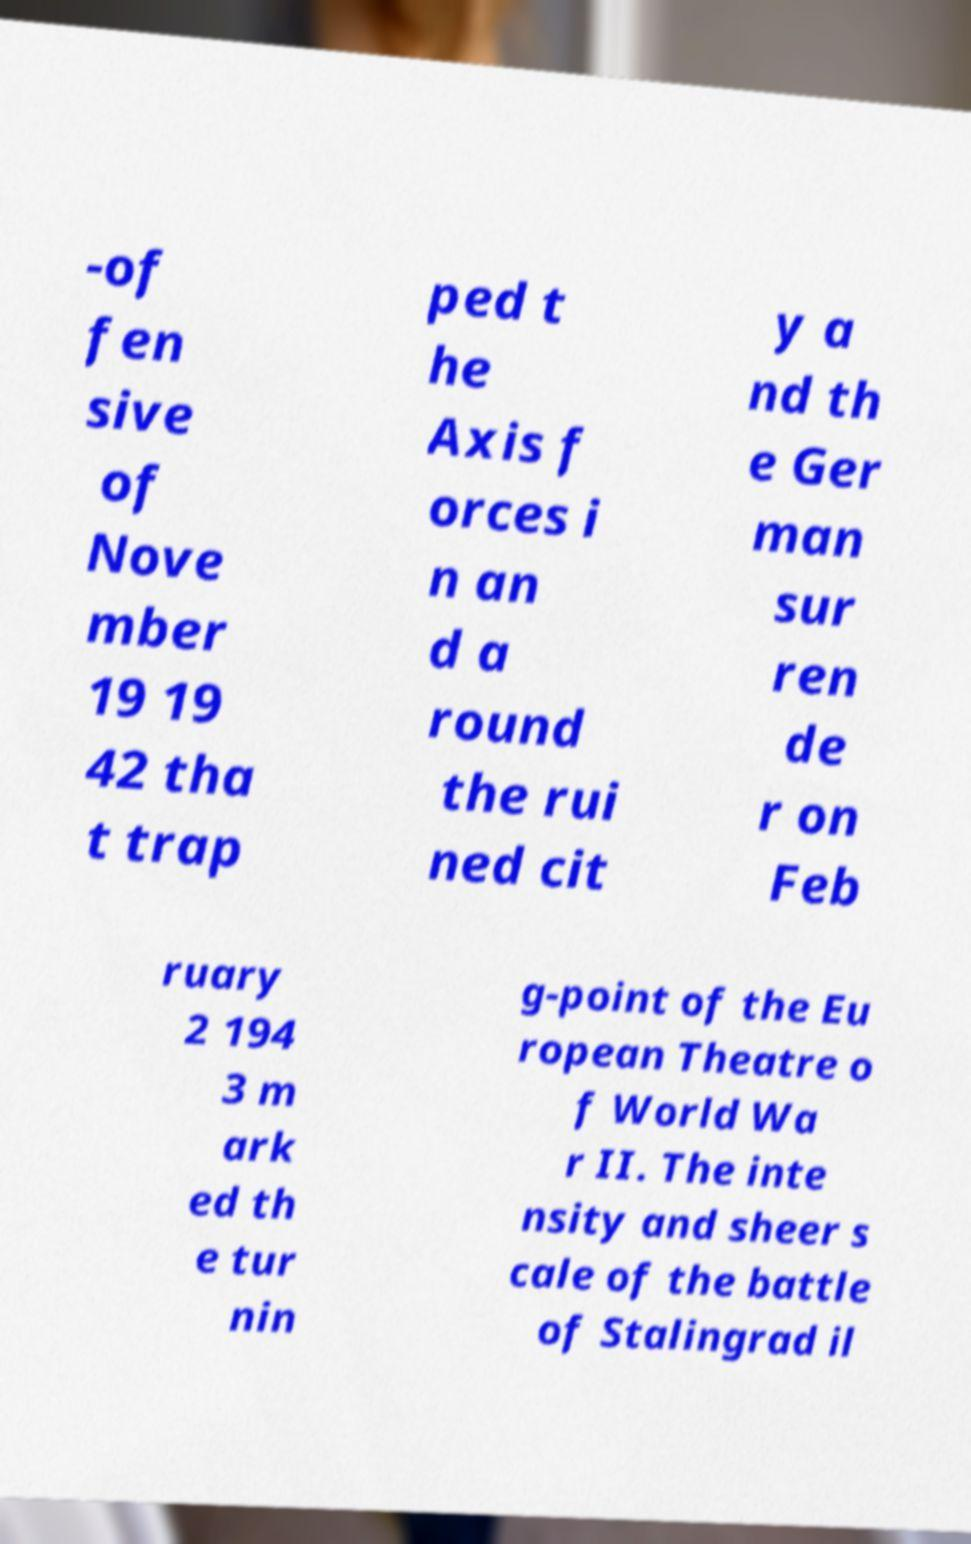Please identify and transcribe the text found in this image. -of fen sive of Nove mber 19 19 42 tha t trap ped t he Axis f orces i n an d a round the rui ned cit y a nd th e Ger man sur ren de r on Feb ruary 2 194 3 m ark ed th e tur nin g-point of the Eu ropean Theatre o f World Wa r II. The inte nsity and sheer s cale of the battle of Stalingrad il 